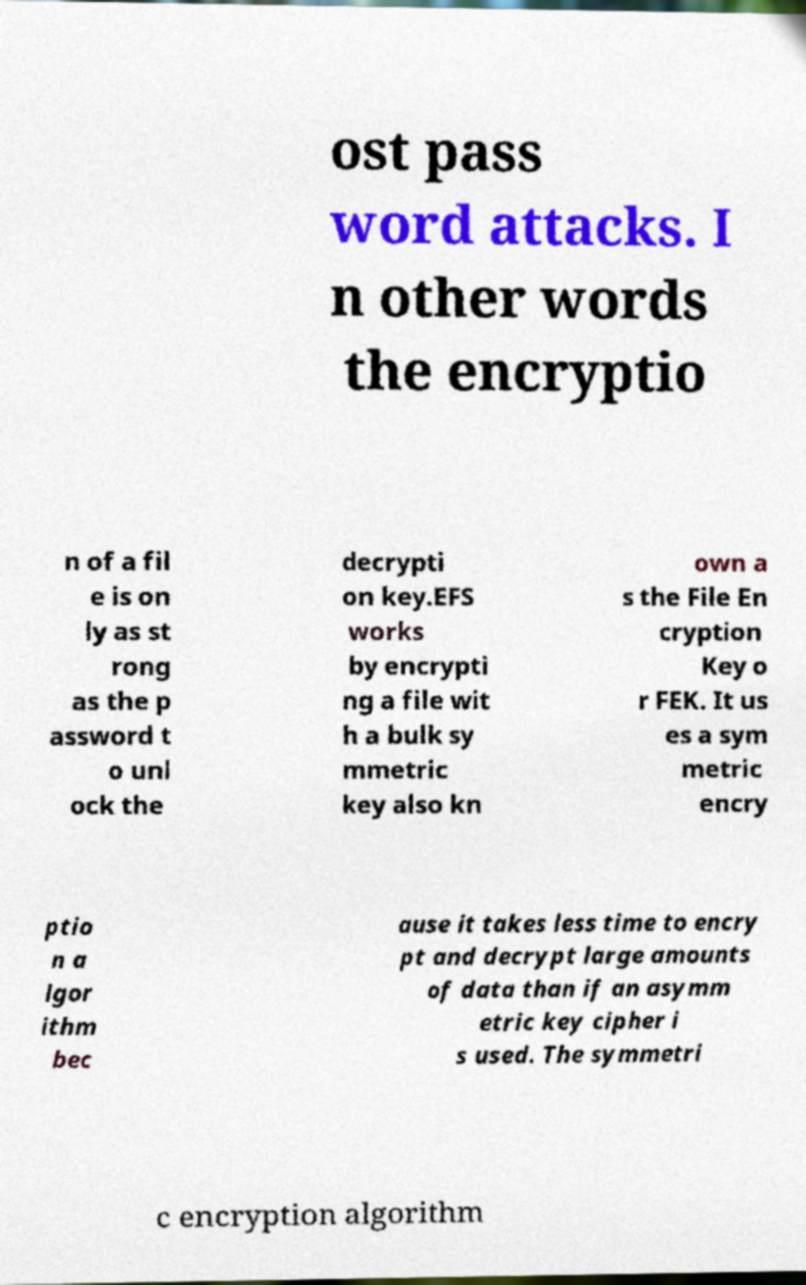What messages or text are displayed in this image? I need them in a readable, typed format. ost pass word attacks. I n other words the encryptio n of a fil e is on ly as st rong as the p assword t o unl ock the decrypti on key.EFS works by encrypti ng a file wit h a bulk sy mmetric key also kn own a s the File En cryption Key o r FEK. It us es a sym metric encry ptio n a lgor ithm bec ause it takes less time to encry pt and decrypt large amounts of data than if an asymm etric key cipher i s used. The symmetri c encryption algorithm 